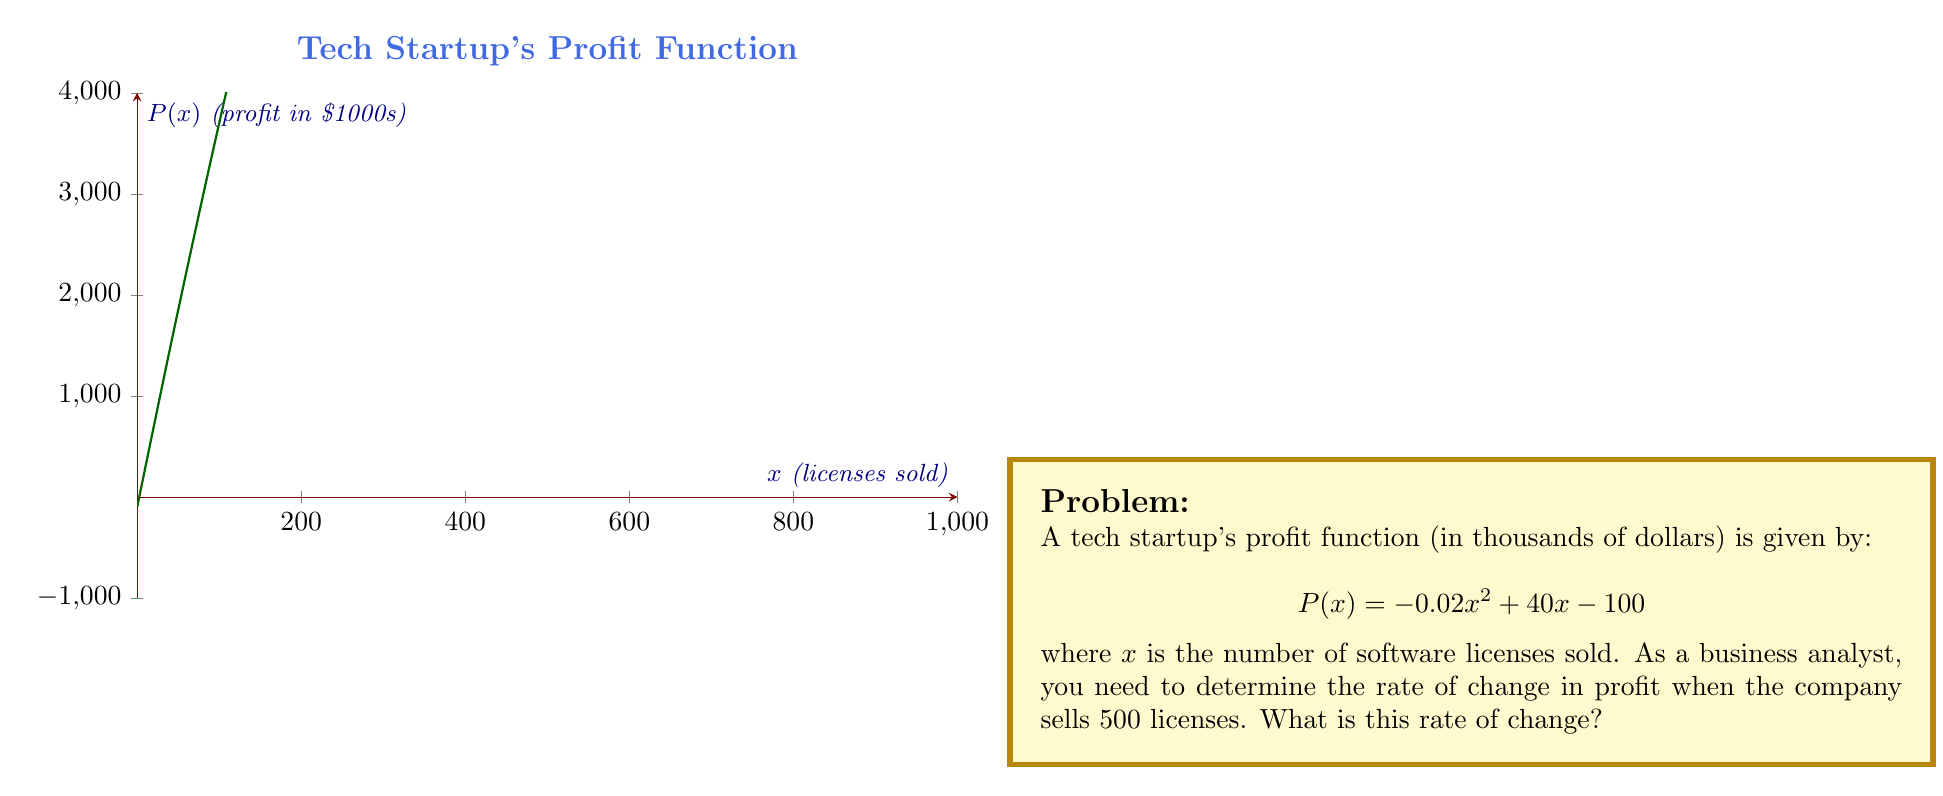Give your solution to this math problem. To solve this problem, we need to follow these steps:

1) The rate of change in profit is given by the derivative of the profit function $P(x)$.

2) Let's find the derivative of $P(x)$:
   $$P'(x) = \frac{d}{dx}(-0.02x^2 + 40x - 100)$$
   $$P'(x) = -0.04x + 40$$

3) Now, we need to evaluate $P'(x)$ at $x = 500$:
   $$P'(500) = -0.04(500) + 40$$
   $$P'(500) = -20 + 40 = 20$$

4) Interpret the result:
   The rate of change when 500 licenses are sold is 20 thousand dollars per license.

This means that, at the point where 500 licenses are sold, selling one more license would increase the profit by approximately $20,000.
Answer: $20$ thousand dollars per license 